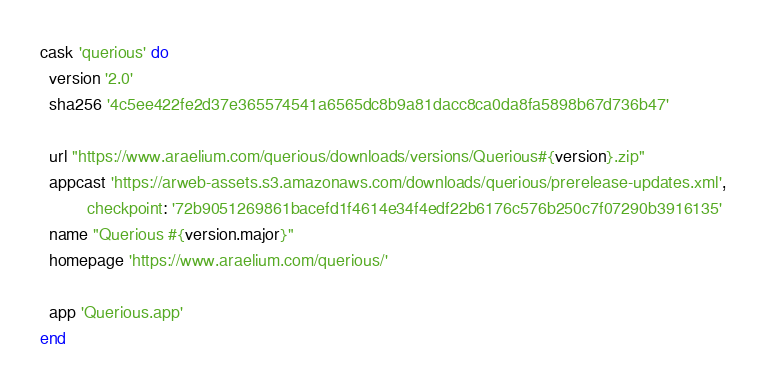Convert code to text. <code><loc_0><loc_0><loc_500><loc_500><_Ruby_>cask 'querious' do
  version '2.0'
  sha256 '4c5ee422fe2d37e365574541a6565dc8b9a81dacc8ca0da8fa5898b67d736b47'

  url "https://www.araelium.com/querious/downloads/versions/Querious#{version}.zip"
  appcast 'https://arweb-assets.s3.amazonaws.com/downloads/querious/prerelease-updates.xml',
          checkpoint: '72b9051269861bacefd1f4614e34f4edf22b6176c576b250c7f07290b3916135'
  name "Querious #{version.major}"
  homepage 'https://www.araelium.com/querious/'

  app 'Querious.app'
end
</code> 